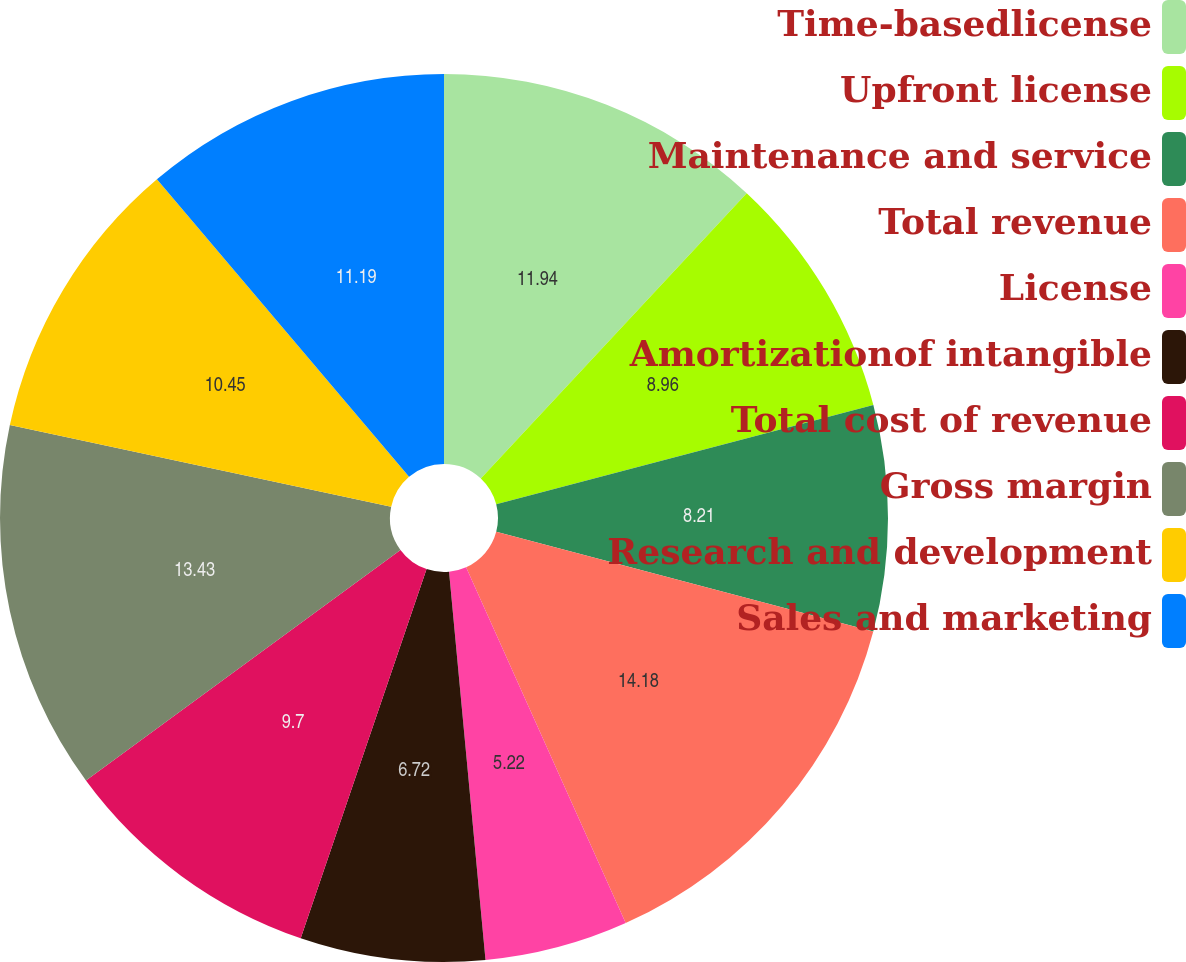Convert chart to OTSL. <chart><loc_0><loc_0><loc_500><loc_500><pie_chart><fcel>Time-basedlicense<fcel>Upfront license<fcel>Maintenance and service<fcel>Total revenue<fcel>License<fcel>Amortizationof intangible<fcel>Total cost of revenue<fcel>Gross margin<fcel>Research and development<fcel>Sales and marketing<nl><fcel>11.94%<fcel>8.96%<fcel>8.21%<fcel>14.18%<fcel>5.22%<fcel>6.72%<fcel>9.7%<fcel>13.43%<fcel>10.45%<fcel>11.19%<nl></chart> 